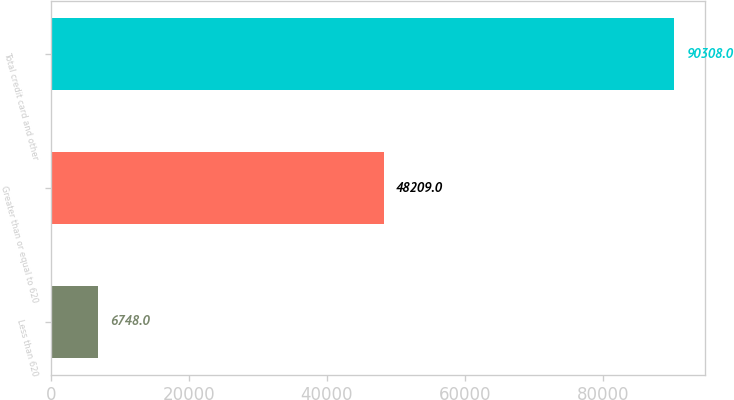Convert chart. <chart><loc_0><loc_0><loc_500><loc_500><bar_chart><fcel>Less than 620<fcel>Greater than or equal to 620<fcel>Total credit card and other<nl><fcel>6748<fcel>48209<fcel>90308<nl></chart> 